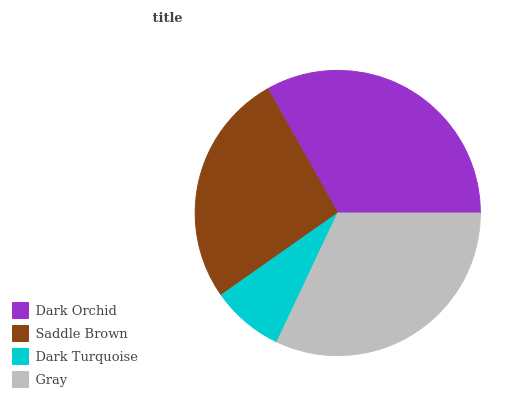Is Dark Turquoise the minimum?
Answer yes or no. Yes. Is Dark Orchid the maximum?
Answer yes or no. Yes. Is Saddle Brown the minimum?
Answer yes or no. No. Is Saddle Brown the maximum?
Answer yes or no. No. Is Dark Orchid greater than Saddle Brown?
Answer yes or no. Yes. Is Saddle Brown less than Dark Orchid?
Answer yes or no. Yes. Is Saddle Brown greater than Dark Orchid?
Answer yes or no. No. Is Dark Orchid less than Saddle Brown?
Answer yes or no. No. Is Gray the high median?
Answer yes or no. Yes. Is Saddle Brown the low median?
Answer yes or no. Yes. Is Saddle Brown the high median?
Answer yes or no. No. Is Dark Turquoise the low median?
Answer yes or no. No. 